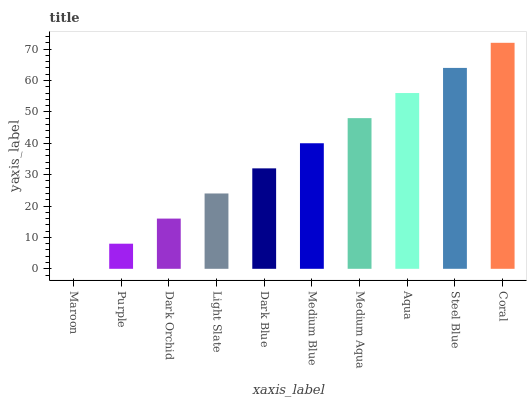Is Maroon the minimum?
Answer yes or no. Yes. Is Coral the maximum?
Answer yes or no. Yes. Is Purple the minimum?
Answer yes or no. No. Is Purple the maximum?
Answer yes or no. No. Is Purple greater than Maroon?
Answer yes or no. Yes. Is Maroon less than Purple?
Answer yes or no. Yes. Is Maroon greater than Purple?
Answer yes or no. No. Is Purple less than Maroon?
Answer yes or no. No. Is Medium Blue the high median?
Answer yes or no. Yes. Is Dark Blue the low median?
Answer yes or no. Yes. Is Dark Blue the high median?
Answer yes or no. No. Is Coral the low median?
Answer yes or no. No. 